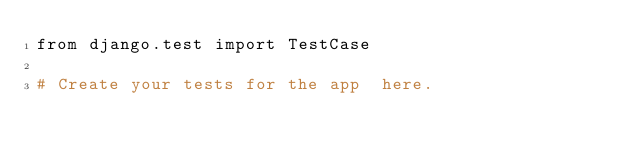Convert code to text. <code><loc_0><loc_0><loc_500><loc_500><_Python_>from django.test import TestCase

# Create your tests for the app  here.
</code> 